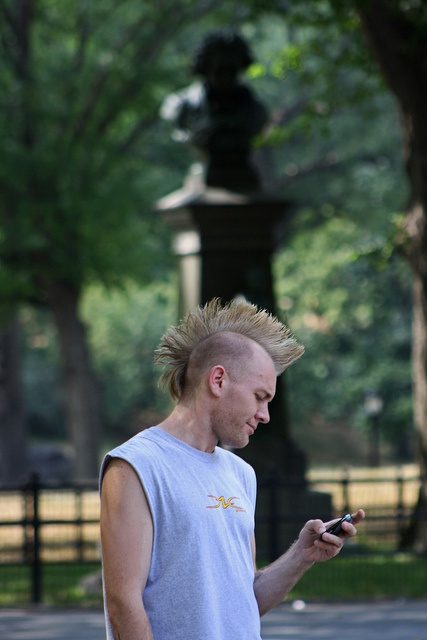Describe the objects in this image and their specific colors. I can see people in black, lightblue, gray, and darkgray tones and cell phone in black, gray, and blue tones in this image. 